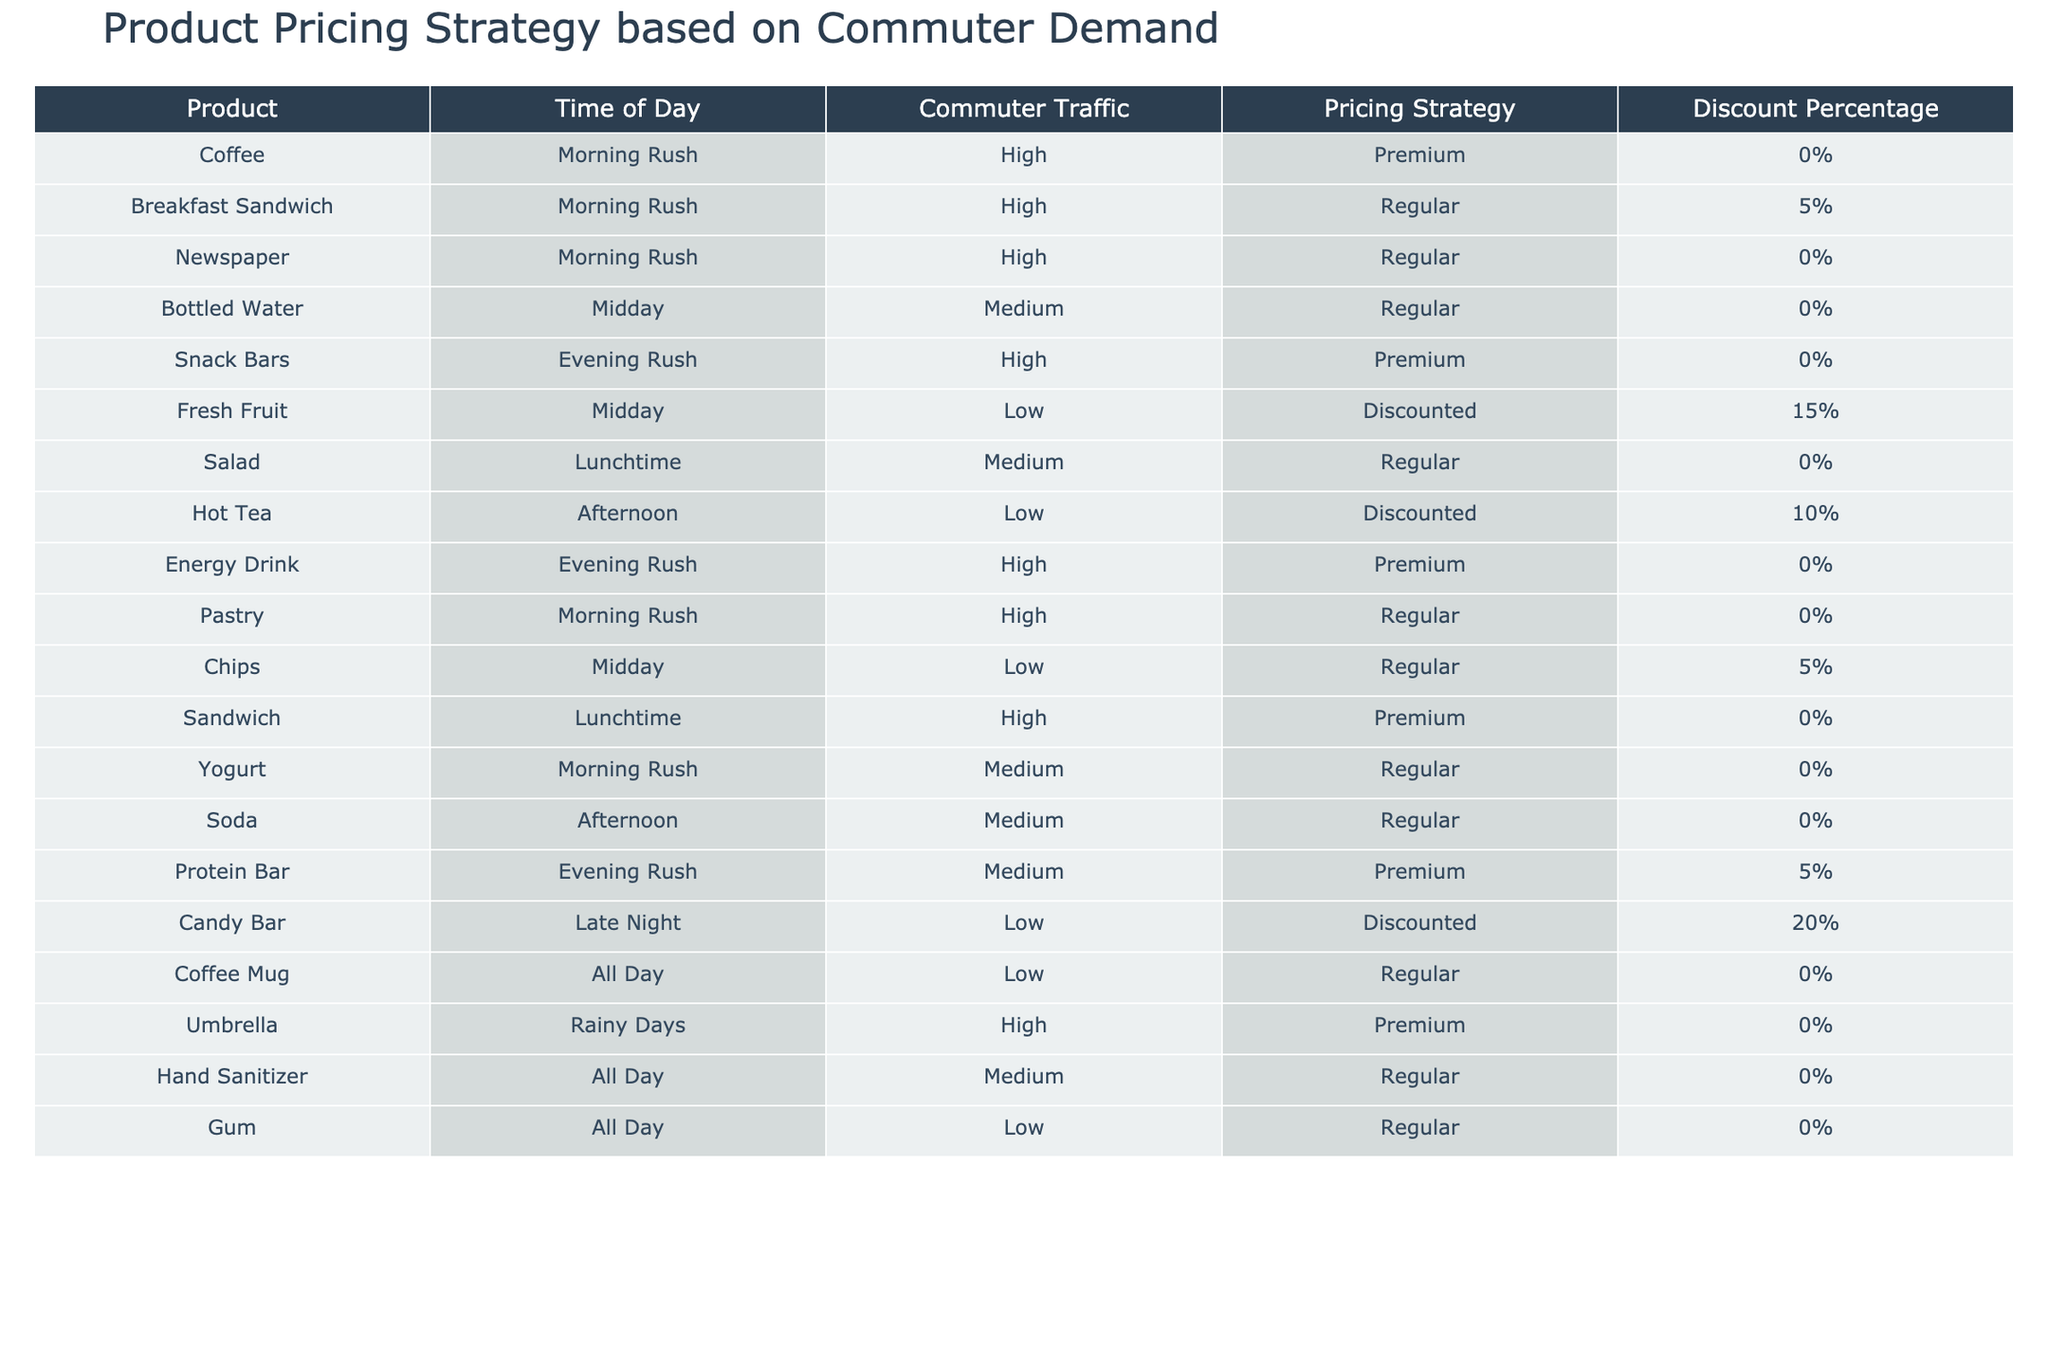What is the pricing strategy for the Breakfast Sandwich? The table indicates that the Breakfast Sandwich has a Pricing Strategy labeled as "Regular" during the Morning Rush.
Answer: Regular How many products have a Premium pricing strategy during the Evening Rush? By inspecting the table, we find that both the Snack Bars and Energy Drink have a Premium pricing strategy listed for the Evening Rush. Thus, there are 2 products in total.
Answer: 2 Is there a product offered at a discounted price during the Afternoon? By reviewing the table, we see that there is one product, Hot Tea, listed as having a discounted price during the Afternoon.
Answer: Yes Which product has the highest discount percentage, and what is that percentage? Upon examining the discount percentages, we find the Candy Bar has the highest discount percentage at 20%.
Answer: 20% What is the average discount percentage for products not priced as Premium? First, identify the products that are not Premium: Breakfast Sandwich, Bottled Water, Fresh Fruit, Salad, Pastry, Chips, Soda, Coffee Mug, Hand Sanitizer, and Gum. Next, their discount percentages are: 5, 0, 15, 0, 0, 5, 0, 0, and 0, respectively. Summing these gives 25, and there are 10 products, so the average discount percentage is 25/10 = 2.5%.
Answer: 2.5% Which time of day has the highest number of products listed with a Regular pricing strategy? From the table, we check each time of day: Morning Rush has 4 products (Breakfast Sandwich, Newspaper, Pastry, Yogurt), Midday has 3 products (Bottled Water, Chips), Lunchtime has 2 products (Salad), Afternoon has 2 products (Soda), and Evening Rush has 1 product (Protein Bar). The Morning Rush has the highest count of Regular pricing strategy products with 4 entries.
Answer: Morning Rush Are there any products with a discount percentage greater than 10%? By checking the discount percentages in the table, we see that only the Fresh Fruit (15%) and Candy Bar (20%) exceed 10%.
Answer: Yes What is the total number of products with High commuter traffic and a Regular pricing strategy? In the table, we find the products: Breakfast Sandwich and Pastry during Morning Rush, and Salad during Lunchtime. Totaling these, we see that there are 3 products with High commuter traffic priced as Regular.
Answer: 3 